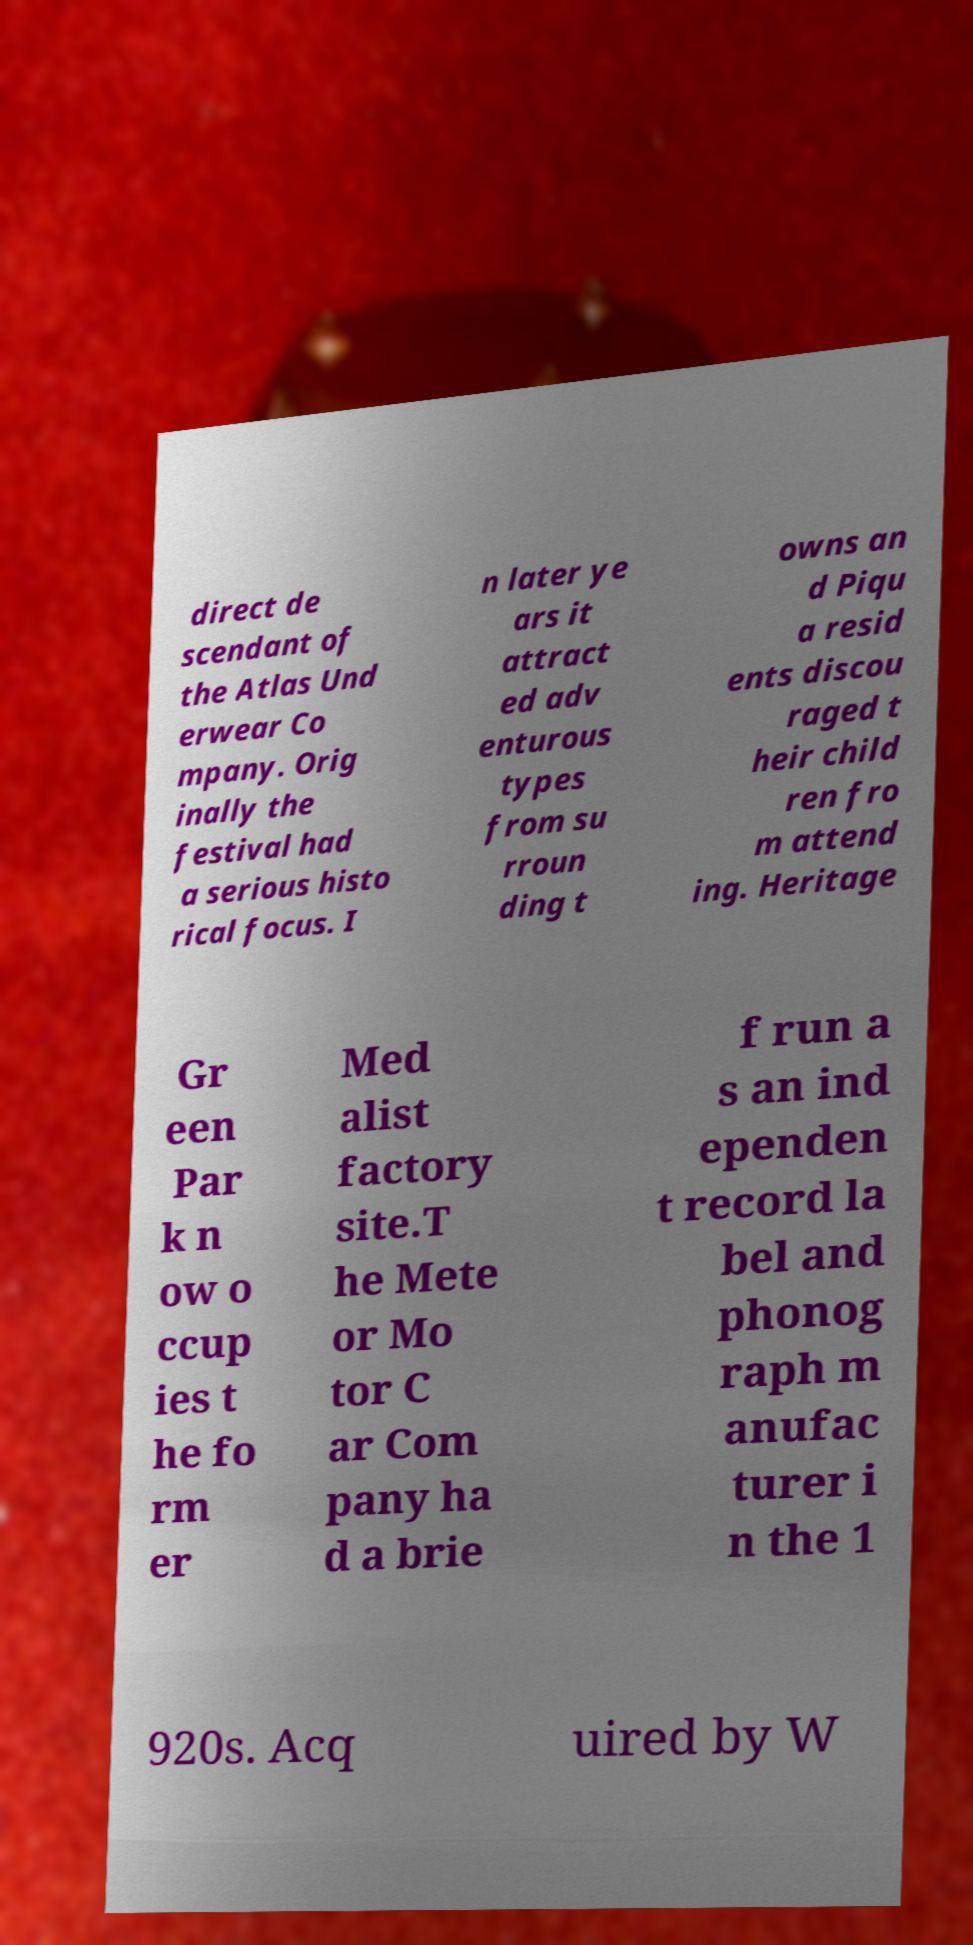I need the written content from this picture converted into text. Can you do that? direct de scendant of the Atlas Und erwear Co mpany. Orig inally the festival had a serious histo rical focus. I n later ye ars it attract ed adv enturous types from su rroun ding t owns an d Piqu a resid ents discou raged t heir child ren fro m attend ing. Heritage Gr een Par k n ow o ccup ies t he fo rm er Med alist factory site.T he Mete or Mo tor C ar Com pany ha d a brie f run a s an ind ependen t record la bel and phonog raph m anufac turer i n the 1 920s. Acq uired by W 